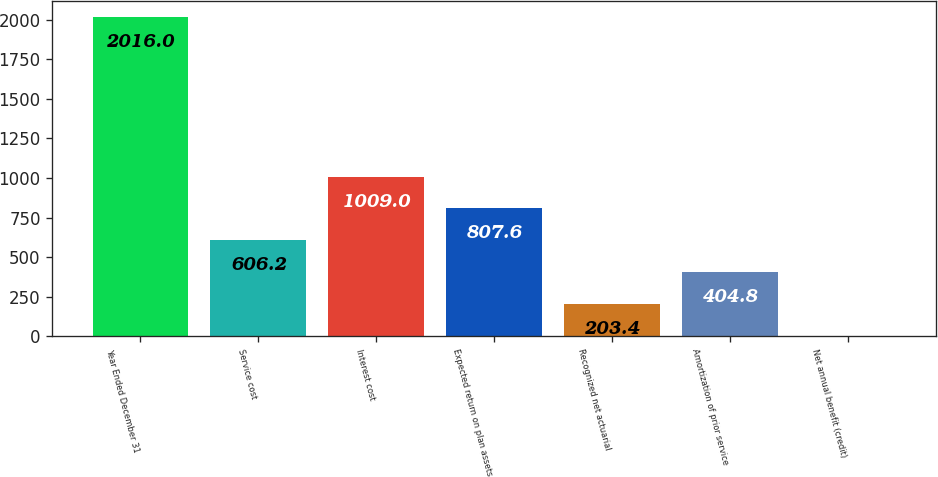Convert chart to OTSL. <chart><loc_0><loc_0><loc_500><loc_500><bar_chart><fcel>Year Ended December 31<fcel>Service cost<fcel>Interest cost<fcel>Expected return on plan assets<fcel>Recognized net actuarial<fcel>Amortization of prior service<fcel>Net annual benefit (credit)<nl><fcel>2016<fcel>606.2<fcel>1009<fcel>807.6<fcel>203.4<fcel>404.8<fcel>2<nl></chart> 